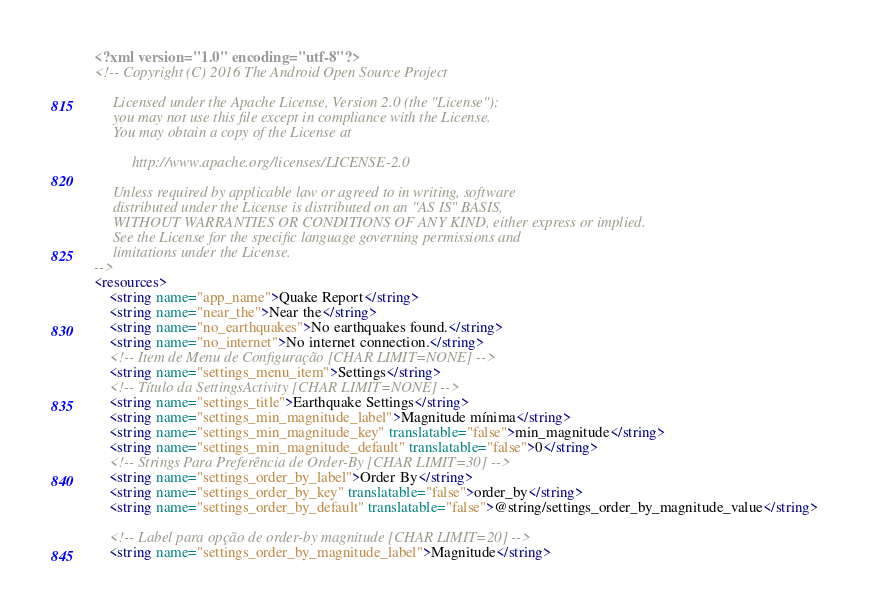Convert code to text. <code><loc_0><loc_0><loc_500><loc_500><_XML_><?xml version="1.0" encoding="utf-8"?>
<!-- Copyright (C) 2016 The Android Open Source Project

     Licensed under the Apache License, Version 2.0 (the "License");
     you may not use this file except in compliance with the License.
     You may obtain a copy of the License at

          http://www.apache.org/licenses/LICENSE-2.0

     Unless required by applicable law or agreed to in writing, software
     distributed under the License is distributed on an "AS IS" BASIS,
     WITHOUT WARRANTIES OR CONDITIONS OF ANY KIND, either express or implied.
     See the License for the specific language governing permissions and
     limitations under the License.
-->
<resources>
    <string name="app_name">Quake Report</string>
    <string name="near_the">Near the</string>
    <string name="no_earthquakes">No earthquakes found.</string>
    <string name="no_internet">No internet connection.</string>
    <!-- Item de Menu de Configuração [CHAR LIMIT=NONE] -->
    <string name="settings_menu_item">Settings</string>
    <!-- Título da SettingsActivity [CHAR LIMIT=NONE] -->
    <string name="settings_title">Earthquake Settings</string>
    <string name="settings_min_magnitude_label">Magnitude mínima</string>
    <string name="settings_min_magnitude_key" translatable="false">min_magnitude</string>
    <string name="settings_min_magnitude_default" translatable="false">0</string>
    <!-- Strings Para Preferência de Order-By [CHAR LIMIT=30] -->
    <string name="settings_order_by_label">Order By</string>
    <string name="settings_order_by_key" translatable="false">order_by</string>
    <string name="settings_order_by_default" translatable="false">@string/settings_order_by_magnitude_value</string>

    <!-- Label para opção de order-by magnitude [CHAR LIMIT=20] -->
    <string name="settings_order_by_magnitude_label">Magnitude</string></code> 